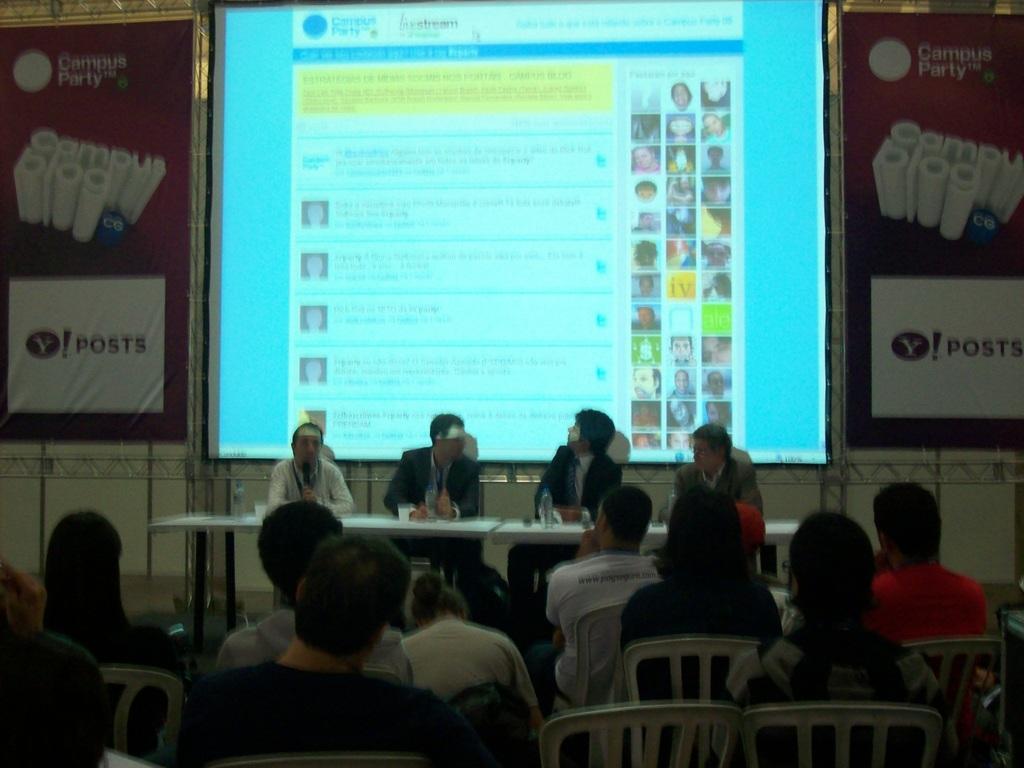Describe this image in one or two sentences. In this picture there are group of people sitting behind the tables and there are bottles and glasses on the tables. In the foreground there are group of people sitting on the chairs. At the back there is a screen and there is a text on the screen and there are hoardings and there is a text hoardings. 